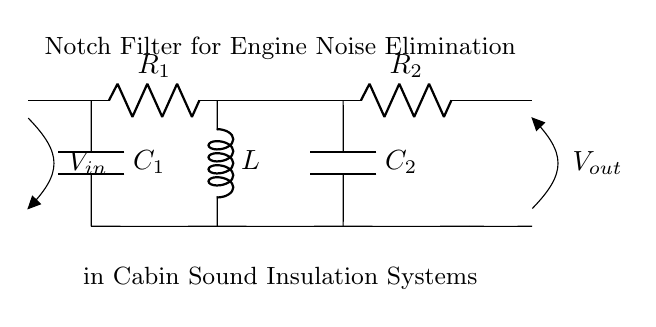What components are present in this circuit? The circuit contains two resistors, two capacitors, and one inductor. Identifying the components from the diagram, we see R1, R2, C1, C2, and L listed clearly.
Answer: Resistors, capacitors, inductor What is the purpose of this circuit? The circuit is designed to serve as a notch filter to eliminate specific engine noise frequencies. This is indicated by the title in the diagram and is typical of circuits meant for sound insulation.
Answer: Notch filter What are the values of the resistors? The diagram lists two resistors, R1 and R2, although their specific numerical values are not provided in the diagram. The answer reflects the information from the circuit and does not assume values.
Answer: R1, R2 What type of filter is this circuit? The circuit is a notch filter, as indicated in the title. A notch filter is specifically designed to attenuate a narrow band of frequencies, making it suitable for eliminating unwanted engine noise.
Answer: Notch filter Which component determines the frequency to be eliminated? The inductor L and the capacitors C1 and C2 work together to set the notch frequency. Their values determine which specific frequencies the filter will target for attenuation.
Answer: Inductor and capacitors How many voltage inputs does this circuit have? The circuit has one voltage input, designated as Vin. This input connects the circuit to the source of the engine noise that needs filtering.
Answer: One 